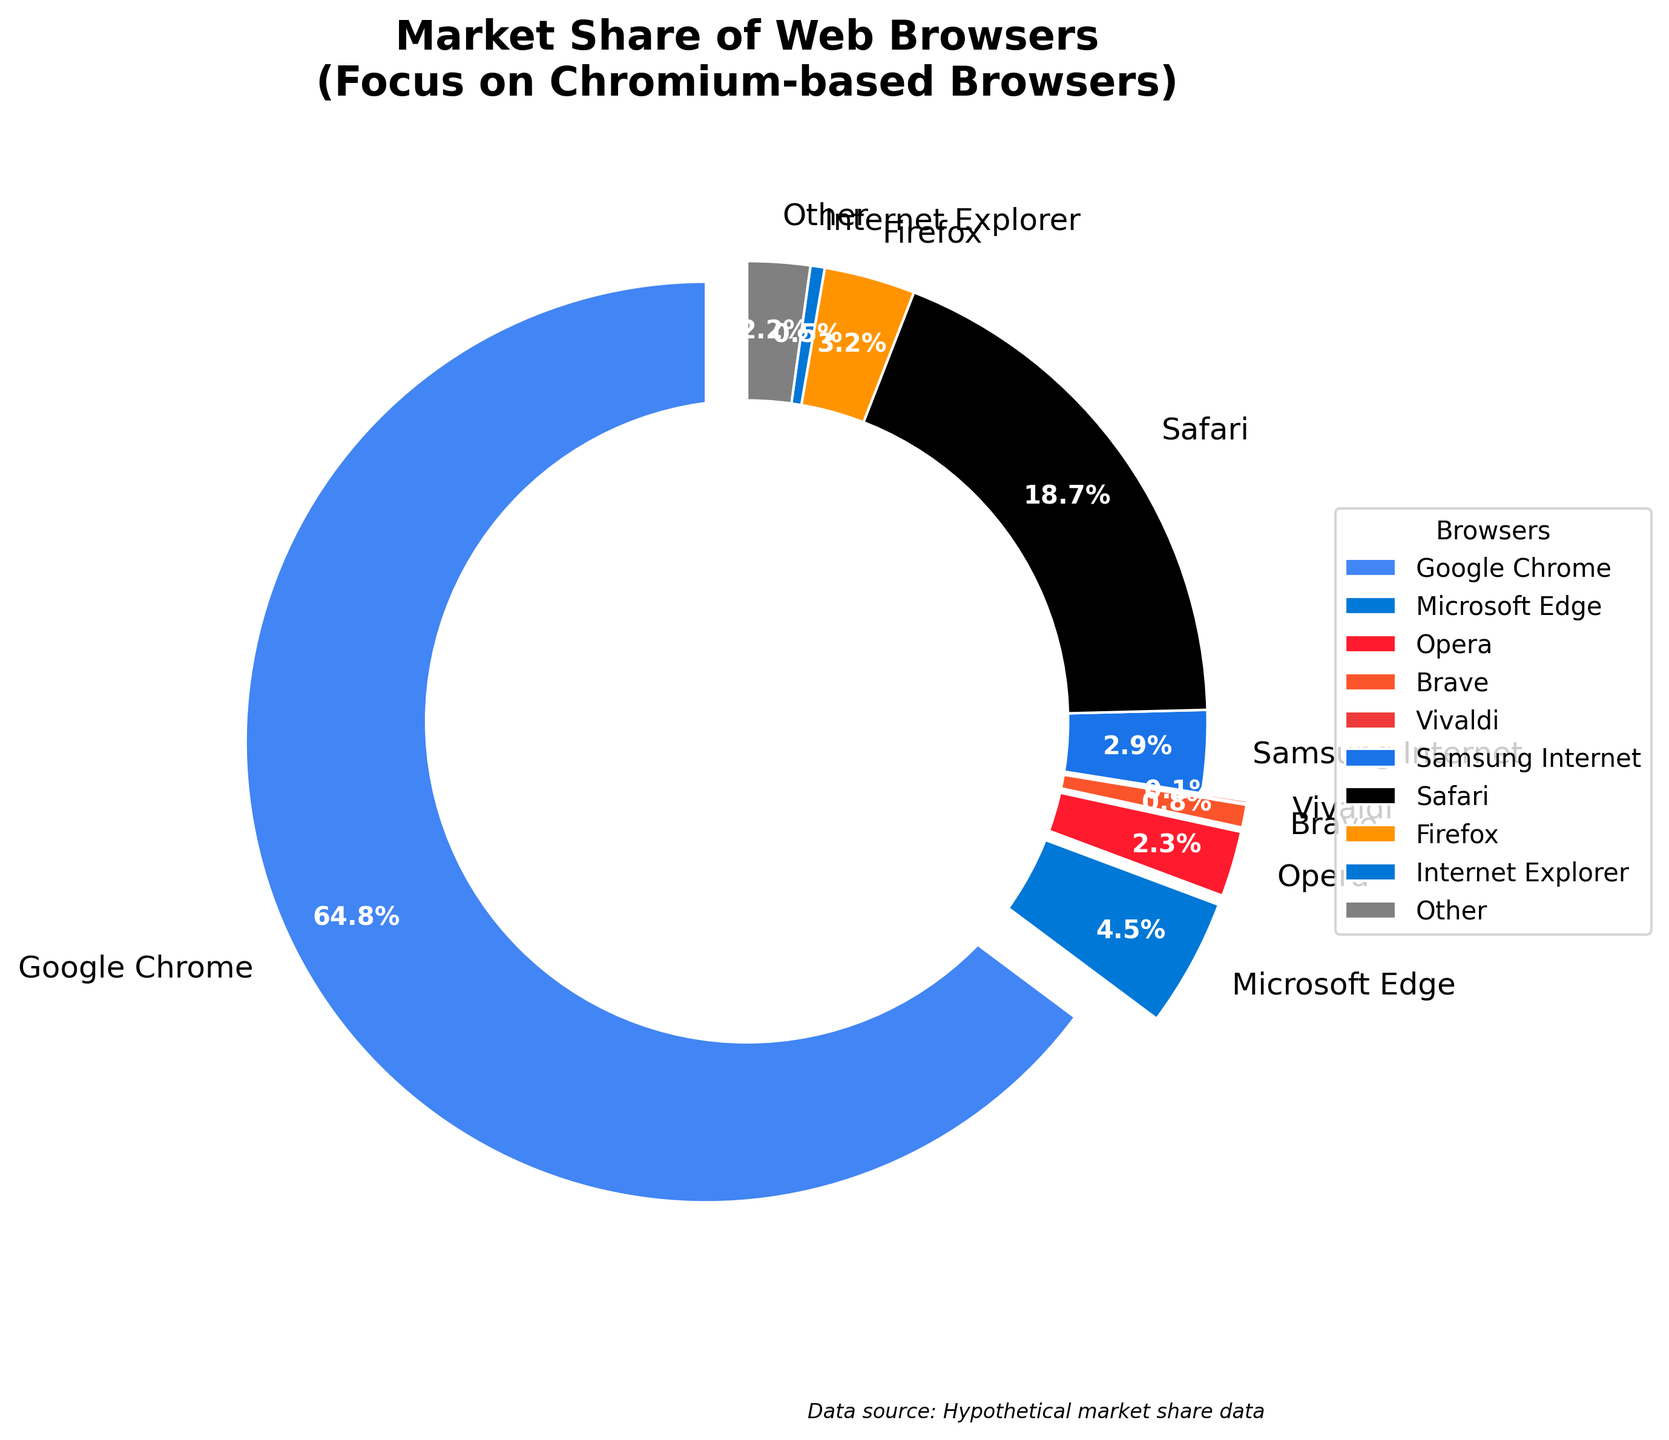What is the combined market share of all Chromium-based browsers? First, identify the Chromium-based browsers which are: Google Chrome (64.8), Microsoft Edge (4.5), Opera (2.3), Brave (0.8), and Vivaldi (0.1). Then sum their market shares: 64.8 + 4.5 + 2.3 + 0.8 + 0.1 = 72.5.
Answer: 72.5 How much larger is the market share of Google Chrome compared to Microsoft Edge? Google Chrome has a market share of 64.8, and Microsoft Edge has 4.5. Subtract the market share of Edge from Chrome: 64.8 - 4.5 = 60.3.
Answer: 60.3 Which web browser has the smallest market share? By looking at the chart, Vivaldi has the smallest market share at 0.1.
Answer: Vivaldi What percentage of the market is held by non-Chromium browsers (e.g., Safari, Firefox)? First identify non-Chromium browsers: Safari (18.7), Firefox (3.2), Internet Explorer (0.5), Samsung Internet (2.9), and Other (2.2). Sum their market shares: 18.7 + 3.2 + 0.5 + 2.9 + 2.2 = 27.5.
Answer: 27.5 Among the Chromium-based browsers, which has the second-largest market share? The market shares for Chromium-based browsers are Google Chrome (64.8), Microsoft Edge (4.5), Opera (2.3), Brave (0.8), and Vivaldi (0.1). The second-largest after Google Chrome is Microsoft Edge with 4.5.
Answer: Microsoft Edge If you combine the market share of Firefox and Internet Explorer, how does it compare to the market share of Opera? First, sum the market shares of Firefox and Internet Explorer: 3.2 + 0.5 = 3.7. Opera has a market share of 2.3. Since 3.7 is greater than 2.3, the combined share of Firefox and Internet Explorer is larger.
Answer: 3.7 is greater than 2.3 What is the visual indicator used to emphasize Chromium-based browsers in the chart? The chart uses an 'explode' effect to emphasize Chromium-based browsers, making their wedges pop out slightly from the pie.
Answer: Explode effect Which browser has the highest market share after Google Chrome and Safari? After Google Chrome (64.8) and Safari (18.7), the browser with the next highest market share is Microsoft Edge with 4.5.
Answer: Microsoft Edge 